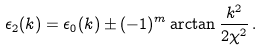<formula> <loc_0><loc_0><loc_500><loc_500>\epsilon _ { 2 } ( k ) = \epsilon _ { 0 } ( k ) \pm ( - 1 ) ^ { m } \arctan \frac { k ^ { 2 } } { 2 \chi ^ { 2 } } \, .</formula> 